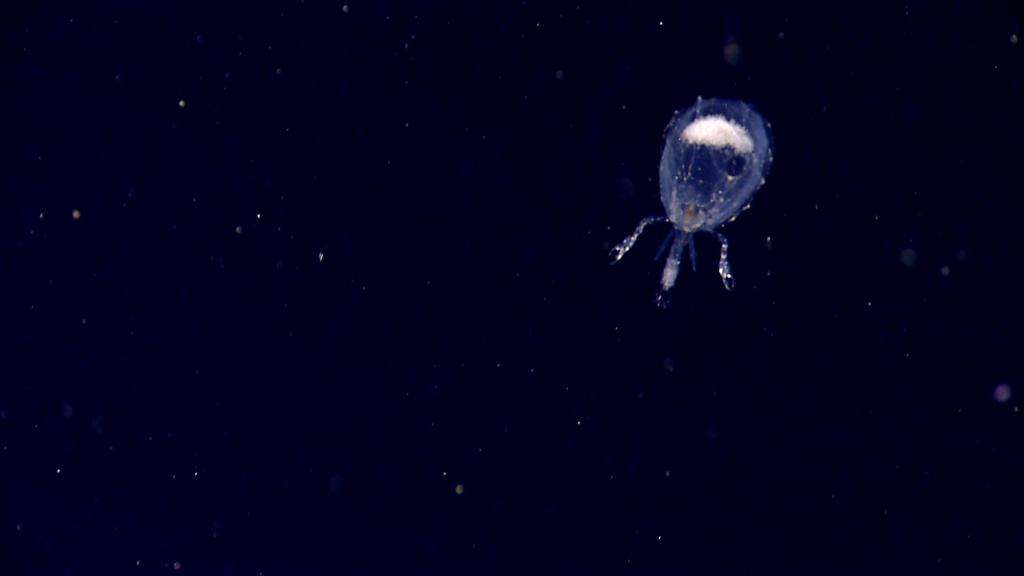What type of creature can be seen in the image? There is an insect in the image. Where is the insect located in the image? The insect is on the right side of the image. What is the color of the background in the image? The background of the image is dark. How much sugar is visible in the image? There is no sugar present in the image. Is the insect part of a family gathering in the image? There is no indication of a family gathering or any other social event in the image. 